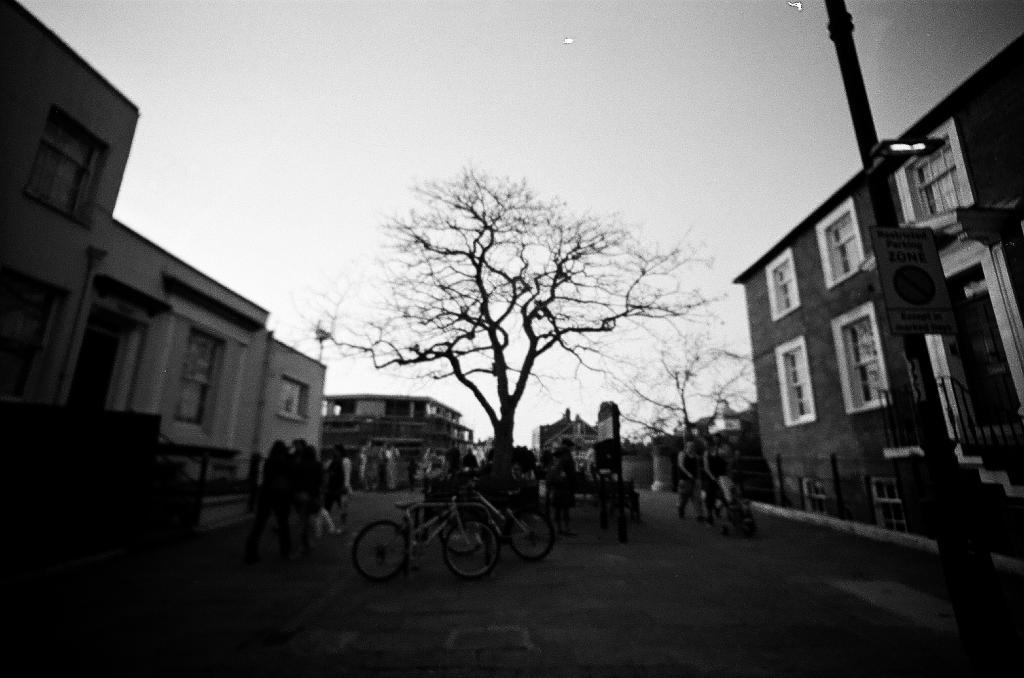What is the color scheme of the image? The image is black and white. What type of vehicles can be seen in the image? There are bicycles in the image. Who or what is present in the image? There are people in the image. What is on the road in the image? There are objects on the road in the image. What can be seen in the distance in the image? There are trees, buildings, windows, and objects visible in the background of the image. What is visible in the sky in the image? The sky is visible in the background of the image. What type of cloth is being used to play a game in the image? There is no cloth or game being played in the image; it is a black and white image featuring bicycles, people, and objects on the road. 